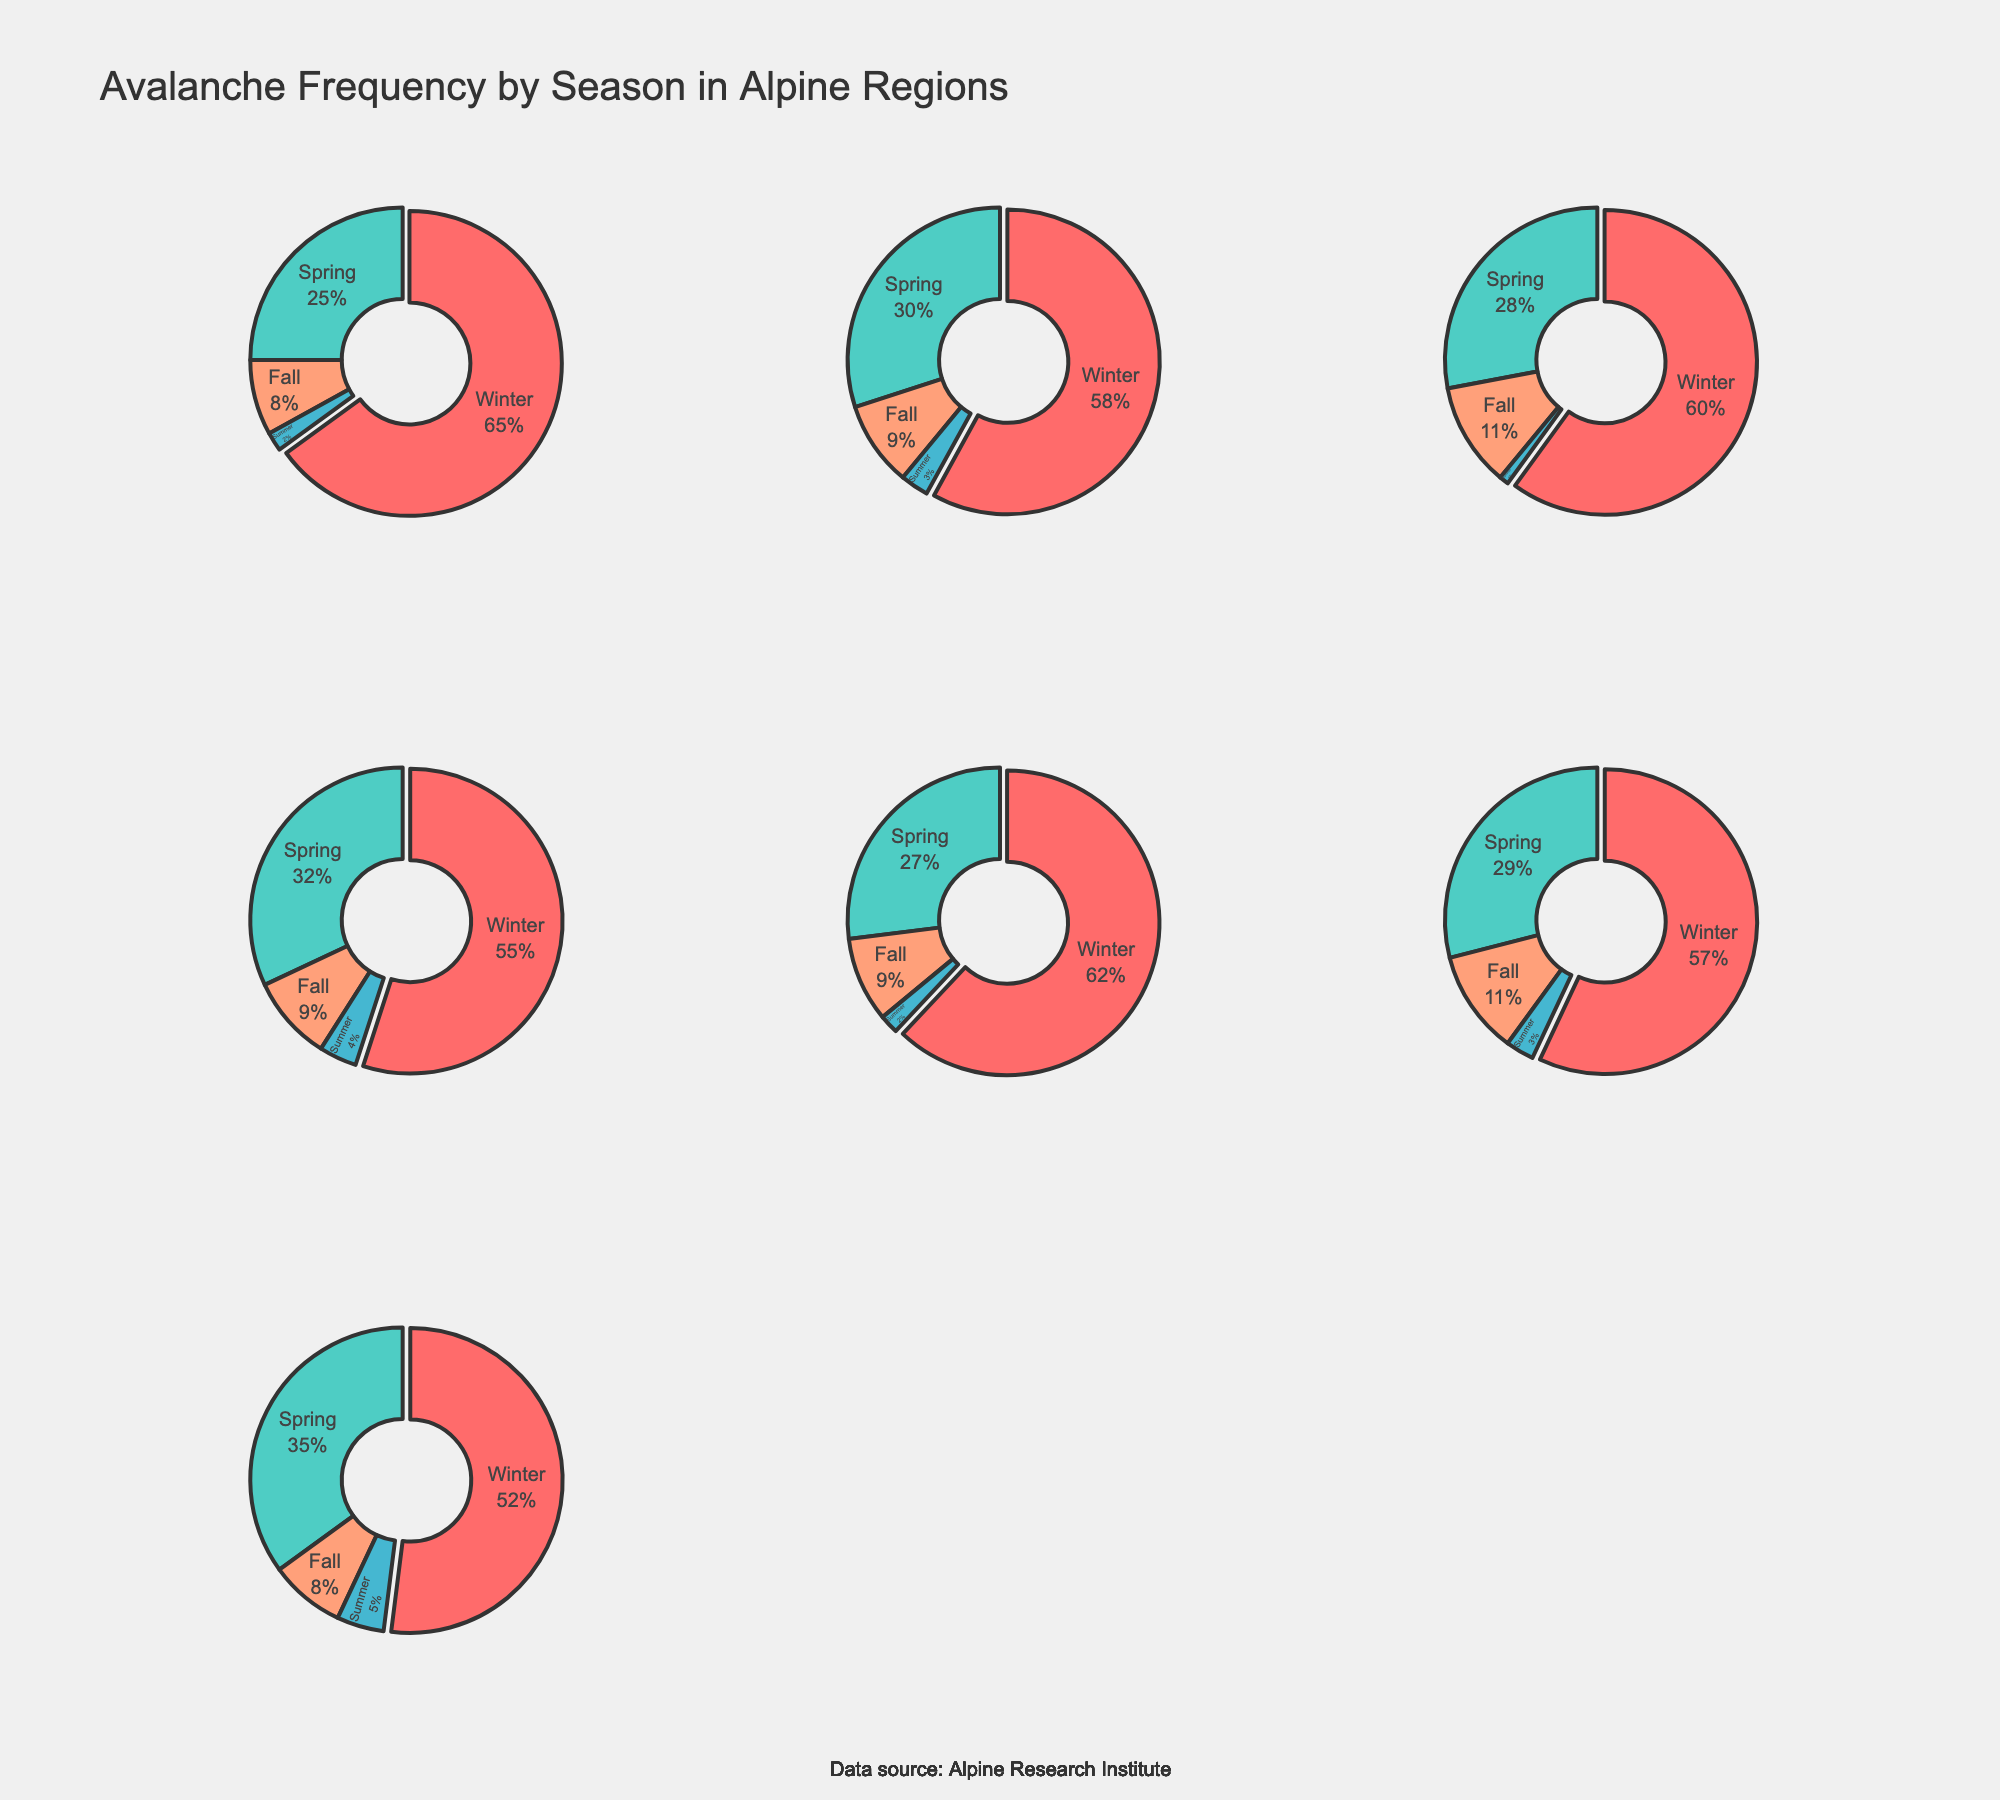What is the title of the figure? The title can be found at the top of the plot. It provides a summary of what the figure represents.
Answer: Avalanche Frequency by Season in Alpine Regions Which alpine region has the largest portion of avalanches occurring in the summer? To answer this, look at each pie chart and compare the slices labeled "Summer." The region with the largest "Summer" slice has the highest avalanche frequency in that season.
Answer: Southern Alps (NZ) What is the combined percentage of avalanches in Spring and Fall for the Rocky Mountains? Locate the pie chart for the Rocky Mountains. Find the percentages for Spring and Fall, then add them together: 30% + 9%.
Answer: 39% Which season has the lowest frequency of avalanches in the Himalayas? Look at the pie chart for the Himalayas and identify the smallest slice. The label of that slice is the answer.
Answer: Summer In which seasons do the Andes have an avalanche frequency above 30%? Examine the pie chart for the Andes and identify which slices are greater than 30%.
Answer: Spring Which region has the highest percentage of winter avalanches? Compare the "Winter" slices across all the pie charts to find the largest one.
Answer: European Alps Compare the percentage of winter avalanches between the European Alps and the Cascasus Mountains. Which region has a higher percentage? Look at the "Winter" slices for both the European Alps and Caucasus Mountains and compare the percentages: 65% for the European Alps and 62% for the Caucasus Mountains.
Answer: European Alps What percentage of avalanches occur in the Fall in the Japanese Alps? Locate the pie chart for the Japanese Alps and find the slice labeled "Fall." The percentage shown on that slice is the answer.
Answer: 11% Which two regions have similar percentages of avalanche occurrences in Spring? Compare the "Spring" slices across all the pie charts and look for similar percentages.
Answer: European Alps and Caucasus Mountains What is the difference in the percentage of summer avalanches between the Southern Alps (NZ) and the Himalayas? Find the "Summer" slices for both the Southern Alps (NZ) and Himalayas, then subtract the smaller percentage from the larger one: 5% - 1% = 4%.
Answer: 4% 